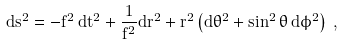<formula> <loc_0><loc_0><loc_500><loc_500>d s ^ { 2 } = - f ^ { 2 } \, d t ^ { 2 } + \frac { 1 } { f ^ { 2 } } d r ^ { 2 } + r ^ { 2 } \left ( d \theta ^ { 2 } + \sin ^ { 2 } \theta \, d \phi ^ { 2 } \right ) \, ,</formula> 